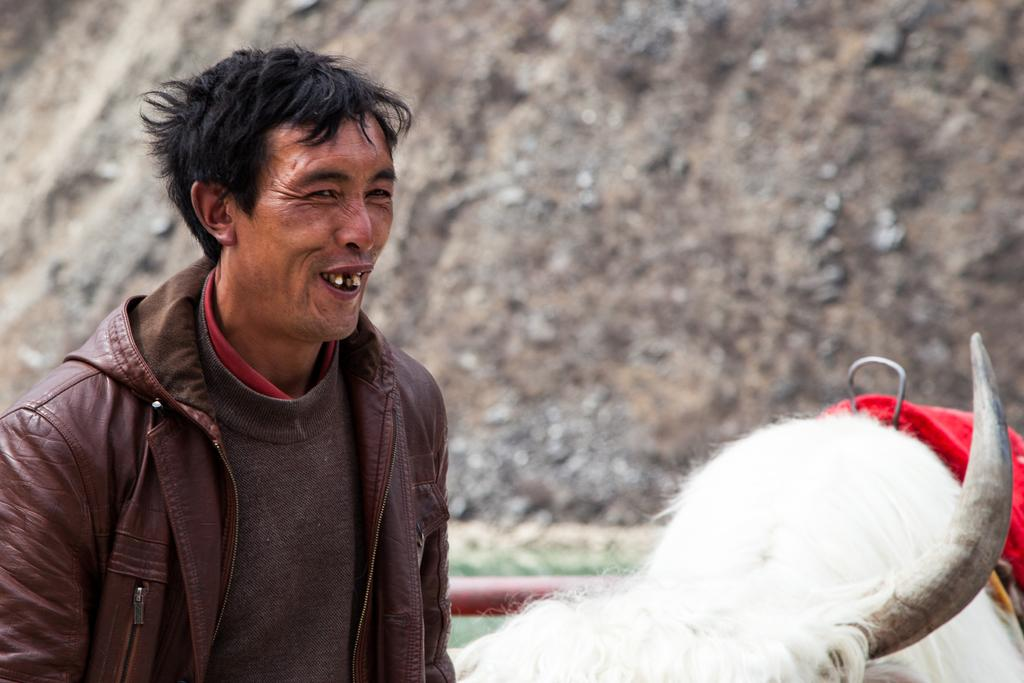What is the main subject of the image? There is a person standing in the image. What is the person wearing? The person is wearing a jacket. How is the person feeling or expressing themselves in the image? The person is laughing. What type of animal is beside the person? There is a white-colored animal beside the person. What type of ear is visible on the person in the image? There is no ear visible on the person in the image; only their face and jacket are visible. 